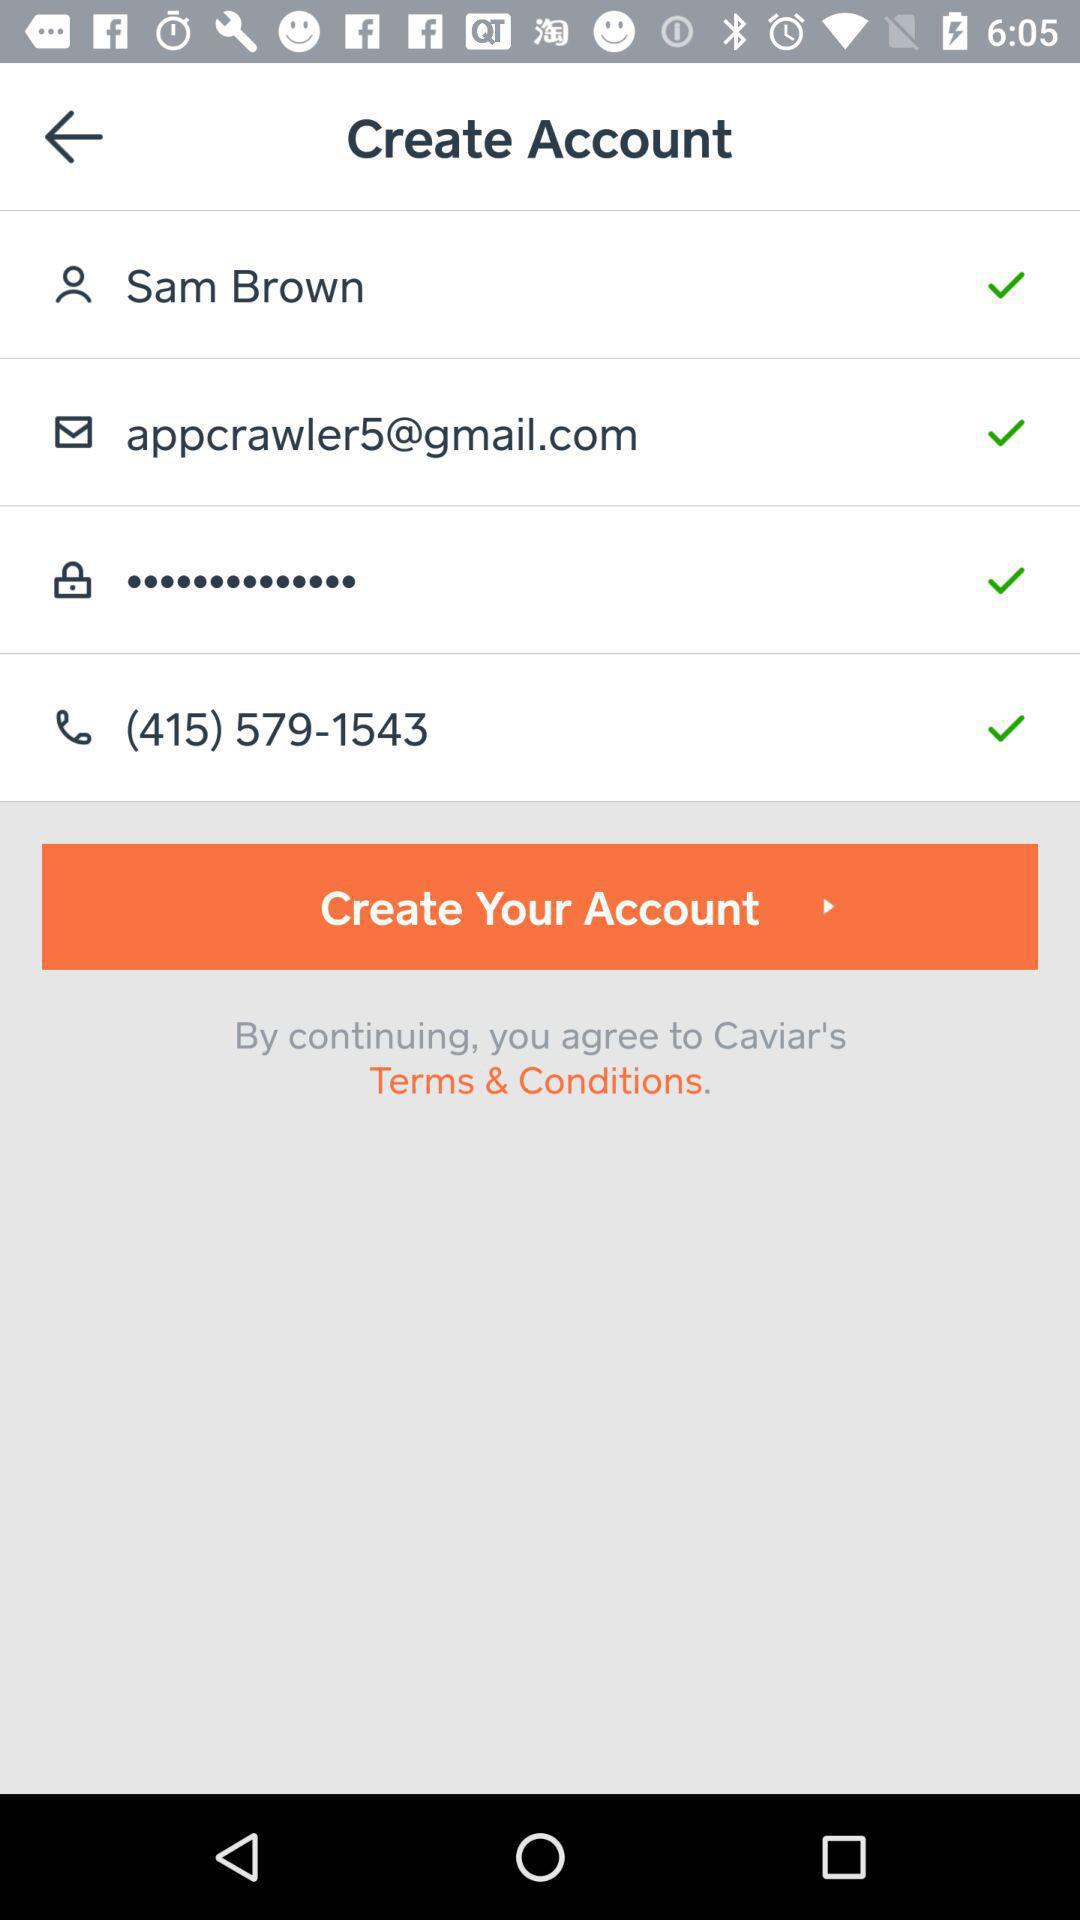What is the phone number? The phone number is (415) 579-1543. 